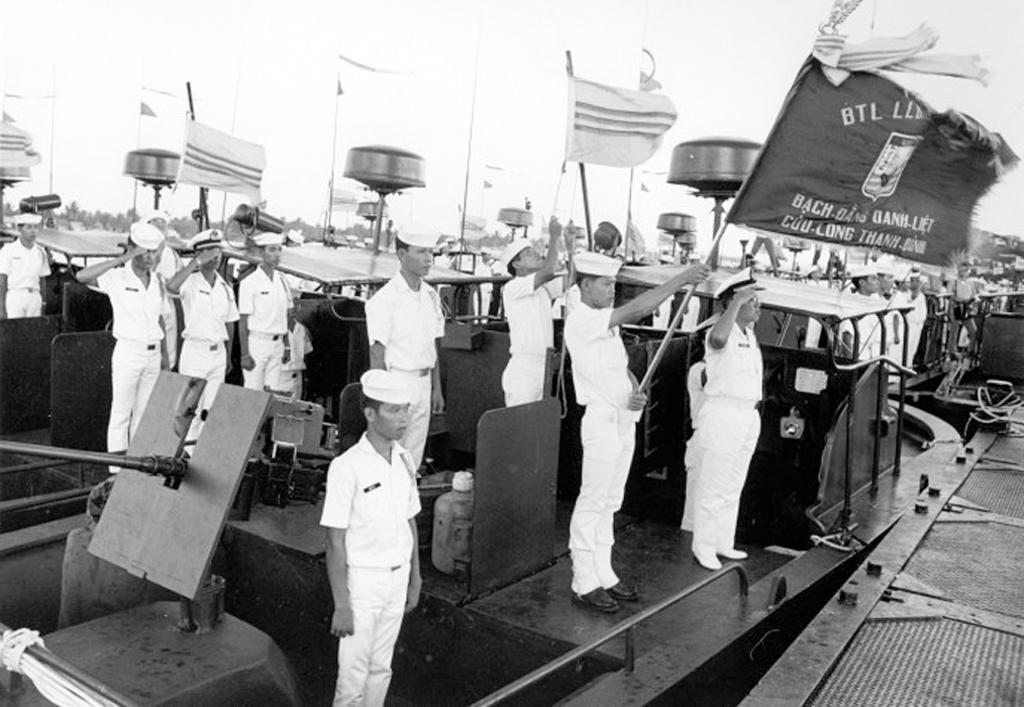Who or what is present in the image? There are people in the image. What are the people doing in the image? The people are standing in a boat. Are there any objects or accessories being held by the people in the image? Yes, some people are holding flags. What type of coat is being worn by the people in the image? There is no mention of coats in the image, as the focus is on the people standing in a boat and holding flags. 